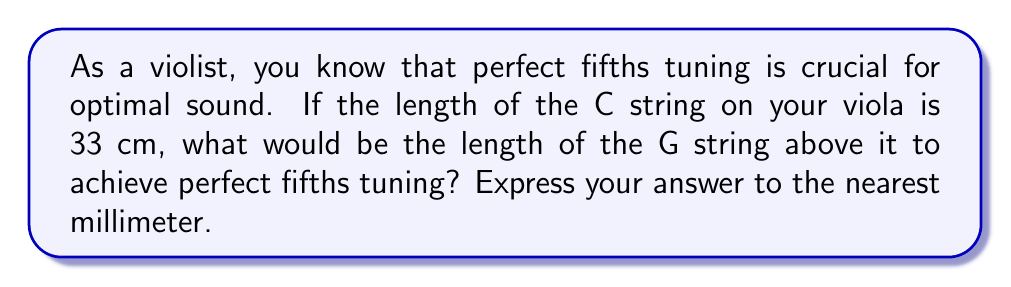Could you help me with this problem? To solve this problem, we need to understand the relationship between string length and pitch in perfect fifths tuning:

1) In perfect fifths tuning, the frequency ratio between two adjacent strings is 3:2.

2) The relationship between frequency (f) and string length (L) is inversely proportional:

   $f \propto \frac{1}{L}$

3) Let $L_C$ be the length of the C string and $L_G$ be the length of the G string.

4) Given the frequency ratio and the inverse relationship with length:

   $\frac{f_G}{f_C} = \frac{3}{2} = \frac{L_C}{L_G}$

5) We can rearrange this to solve for $L_G$:

   $L_G = L_C \cdot \frac{2}{3}$

6) Now, let's substitute the given value:

   $L_G = 33 \text{ cm} \cdot \frac{2}{3} = 22 \text{ cm}$

7) Converting to millimeters:

   $22 \text{ cm} = 220 \text{ mm}$

Therefore, the length of the G string should be 220 mm to achieve perfect fifths tuning with the C string.
Answer: 220 mm 